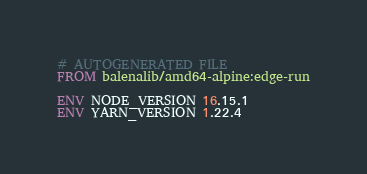Convert code to text. <code><loc_0><loc_0><loc_500><loc_500><_Dockerfile_># AUTOGENERATED FILE
FROM balenalib/amd64-alpine:edge-run

ENV NODE_VERSION 16.15.1
ENV YARN_VERSION 1.22.4
</code> 